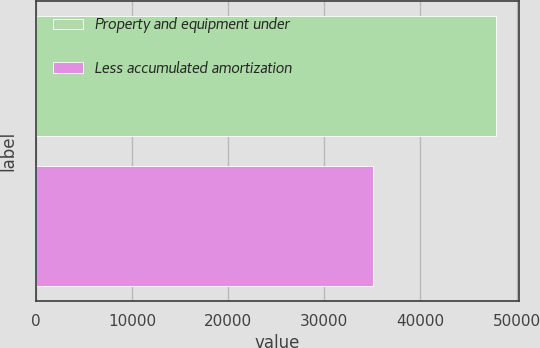Convert chart. <chart><loc_0><loc_0><loc_500><loc_500><bar_chart><fcel>Property and equipment under<fcel>Less accumulated amortization<nl><fcel>47842<fcel>35056<nl></chart> 